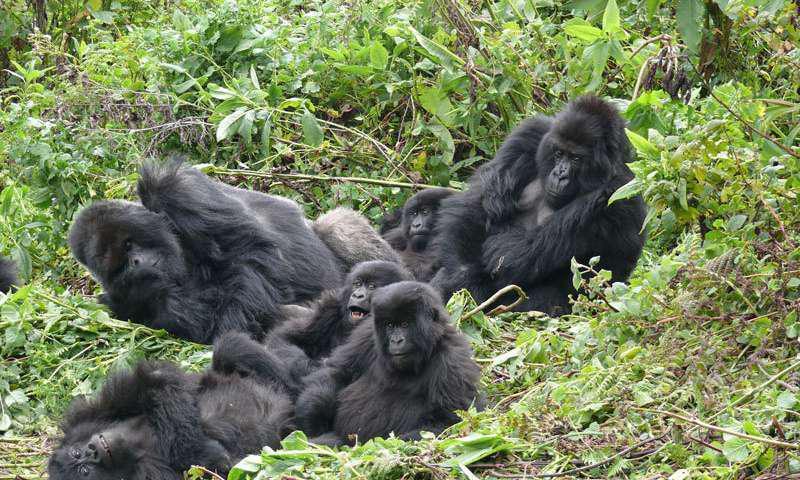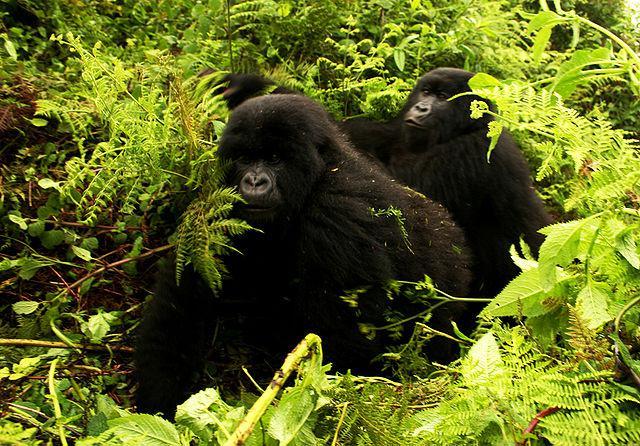The first image is the image on the left, the second image is the image on the right. Analyze the images presented: Is the assertion "An image contains exactly two gorillas, and one is behind the other facing its back but not riding on its back." valid? Answer yes or no. Yes. The first image is the image on the left, the second image is the image on the right. Examine the images to the left and right. Is the description "The left image contains exactly two gorillas." accurate? Answer yes or no. No. 